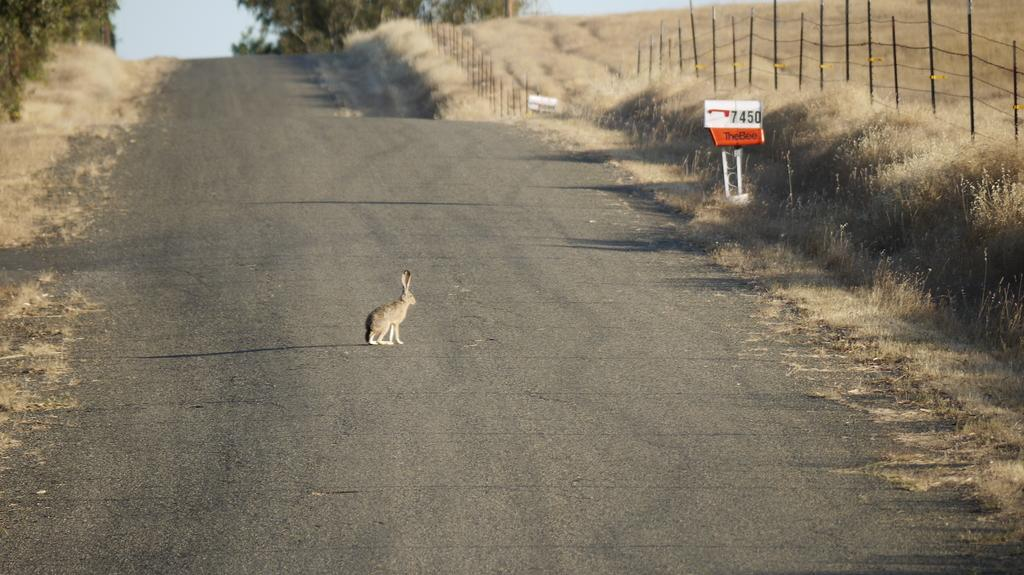What is on the road in the image? There is an animal on the road in the image. What can be seen on the right side of the image? There is fencing on the right side of the image. What type of vegetation is near the fencing? Dried grass is present near the fencing. What is visible in the background of the image? There is sky and trees visible in the background of the image. What type of news can be seen on the cork in the image? There is no cork or news present in the image. What is the heart rate of the animal in the image? There is no information about the animal's heart rate in the image. 